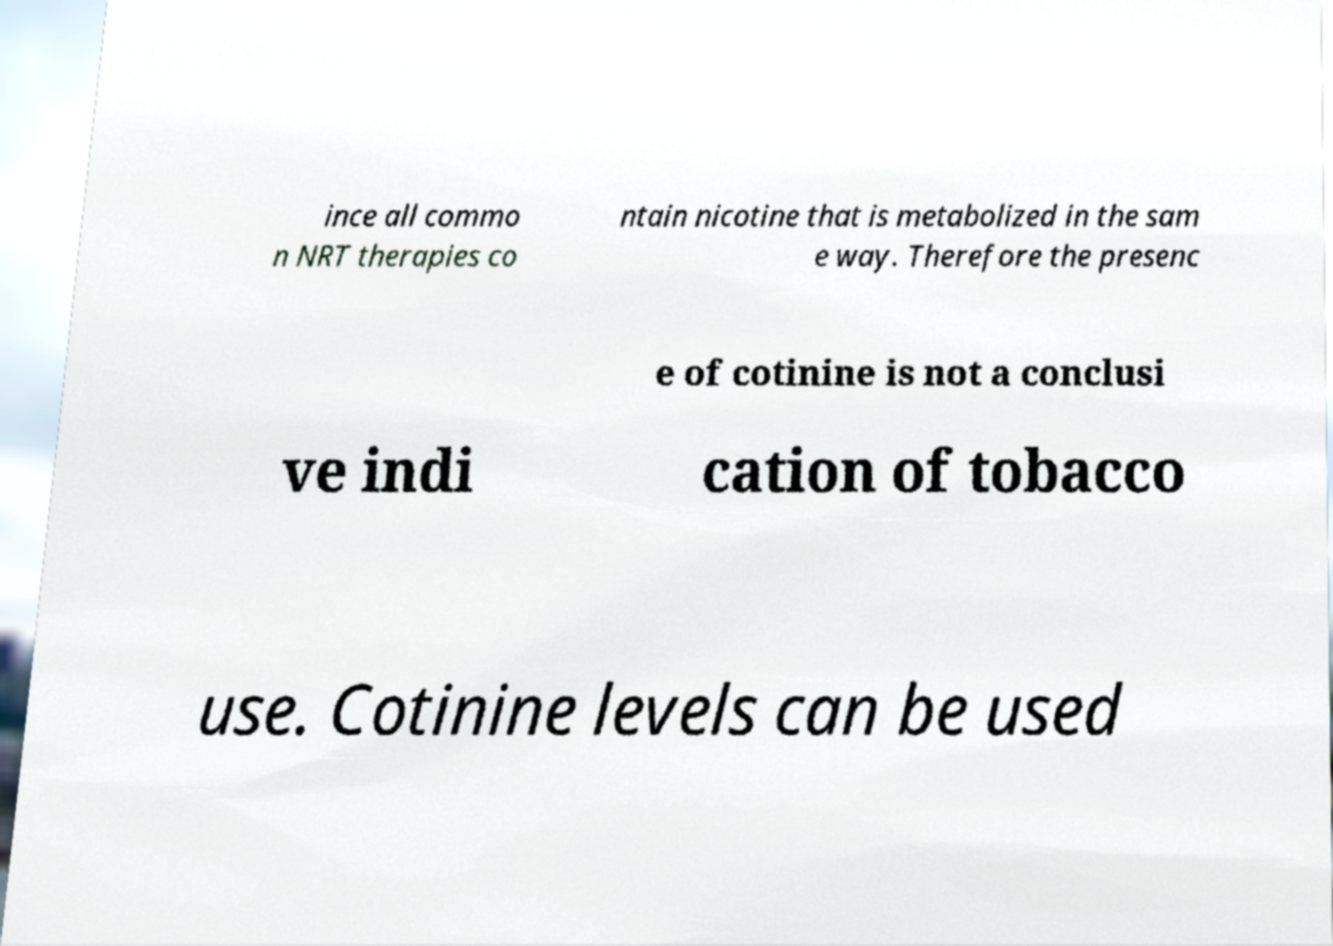Could you extract and type out the text from this image? ince all commo n NRT therapies co ntain nicotine that is metabolized in the sam e way. Therefore the presenc e of cotinine is not a conclusi ve indi cation of tobacco use. Cotinine levels can be used 